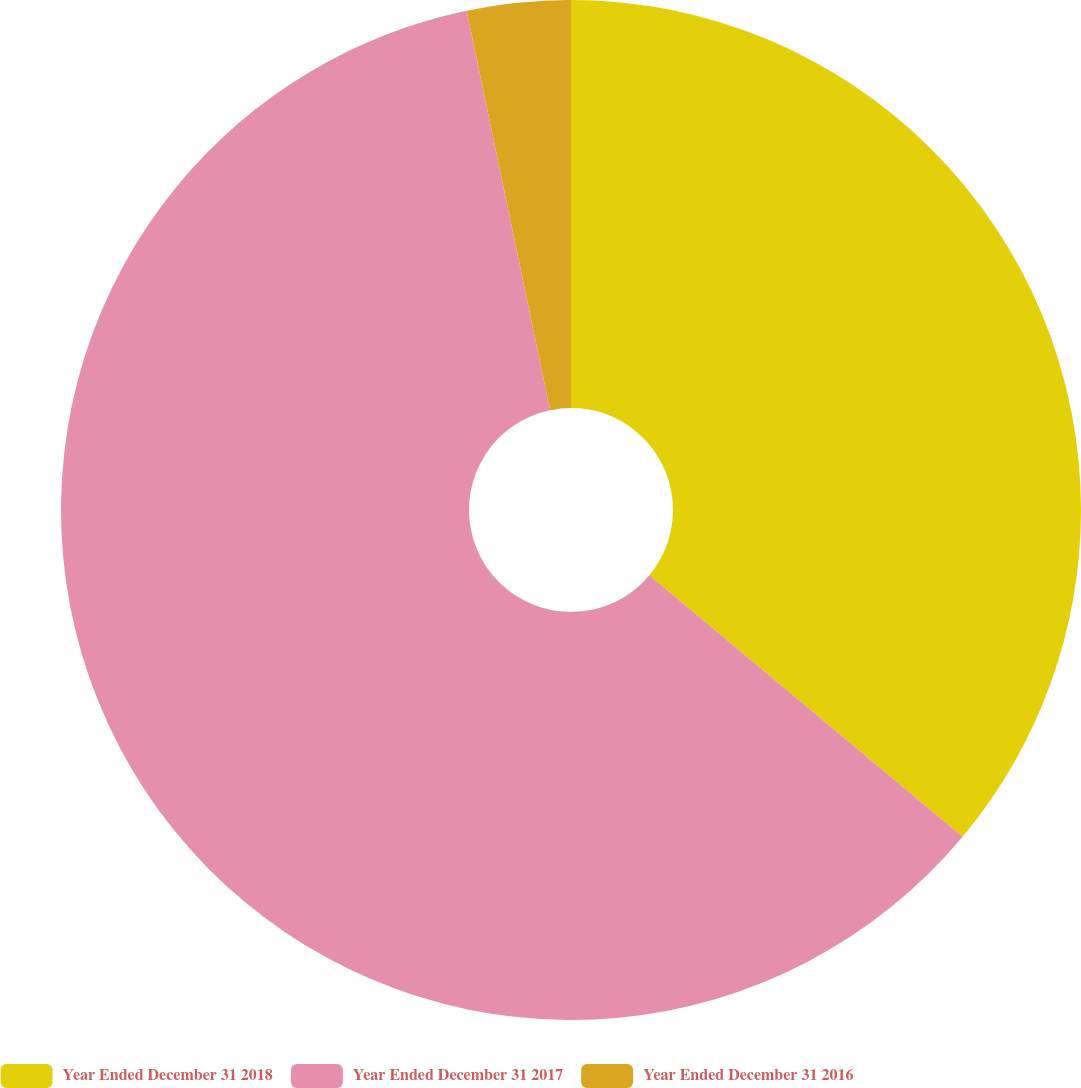Convert chart to OTSL. <chart><loc_0><loc_0><loc_500><loc_500><pie_chart><fcel>Year Ended December 31 2018<fcel>Year Ended December 31 2017<fcel>Year Ended December 31 2016<nl><fcel>36.07%<fcel>60.66%<fcel>3.28%<nl></chart> 